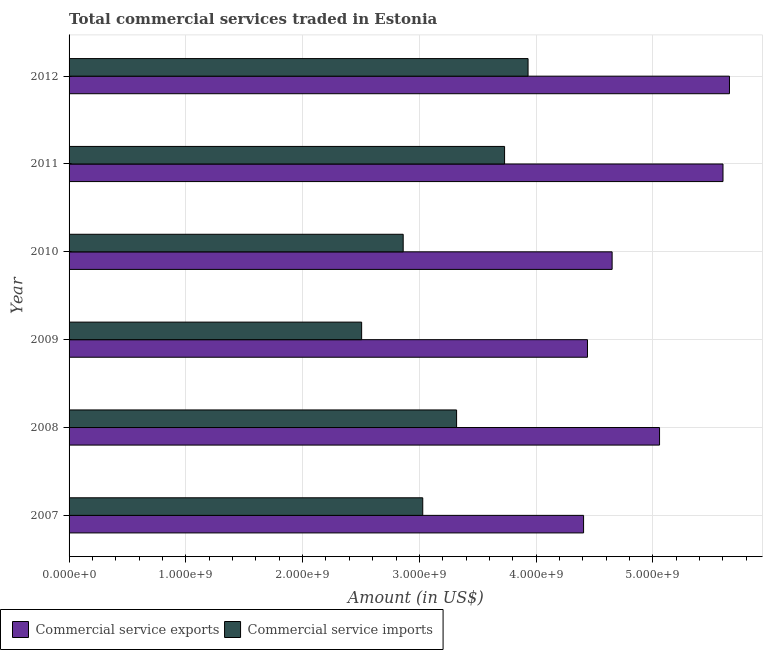How many different coloured bars are there?
Your response must be concise. 2. Are the number of bars per tick equal to the number of legend labels?
Keep it short and to the point. Yes. Are the number of bars on each tick of the Y-axis equal?
Give a very brief answer. Yes. What is the label of the 5th group of bars from the top?
Give a very brief answer. 2008. What is the amount of commercial service exports in 2009?
Your answer should be very brief. 4.44e+09. Across all years, what is the maximum amount of commercial service imports?
Your answer should be compact. 3.93e+09. Across all years, what is the minimum amount of commercial service exports?
Your answer should be very brief. 4.41e+09. In which year was the amount of commercial service exports maximum?
Ensure brevity in your answer.  2012. What is the total amount of commercial service exports in the graph?
Your answer should be compact. 2.98e+1. What is the difference between the amount of commercial service exports in 2007 and that in 2010?
Your answer should be very brief. -2.45e+08. What is the difference between the amount of commercial service exports in 2008 and the amount of commercial service imports in 2011?
Ensure brevity in your answer.  1.33e+09. What is the average amount of commercial service exports per year?
Give a very brief answer. 4.97e+09. In the year 2007, what is the difference between the amount of commercial service exports and amount of commercial service imports?
Your response must be concise. 1.38e+09. Is the difference between the amount of commercial service exports in 2007 and 2010 greater than the difference between the amount of commercial service imports in 2007 and 2010?
Ensure brevity in your answer.  No. What is the difference between the highest and the second highest amount of commercial service exports?
Your answer should be compact. 5.55e+07. What is the difference between the highest and the lowest amount of commercial service imports?
Ensure brevity in your answer.  1.43e+09. What does the 1st bar from the top in 2010 represents?
Give a very brief answer. Commercial service imports. What does the 2nd bar from the bottom in 2011 represents?
Provide a succinct answer. Commercial service imports. How many bars are there?
Your answer should be compact. 12. How many years are there in the graph?
Keep it short and to the point. 6. Does the graph contain any zero values?
Provide a succinct answer. No. What is the title of the graph?
Offer a very short reply. Total commercial services traded in Estonia. What is the label or title of the X-axis?
Your answer should be compact. Amount (in US$). What is the label or title of the Y-axis?
Your response must be concise. Year. What is the Amount (in US$) of Commercial service exports in 2007?
Ensure brevity in your answer.  4.41e+09. What is the Amount (in US$) of Commercial service imports in 2007?
Make the answer very short. 3.03e+09. What is the Amount (in US$) of Commercial service exports in 2008?
Make the answer very short. 5.06e+09. What is the Amount (in US$) of Commercial service imports in 2008?
Offer a terse response. 3.32e+09. What is the Amount (in US$) in Commercial service exports in 2009?
Keep it short and to the point. 4.44e+09. What is the Amount (in US$) of Commercial service imports in 2009?
Ensure brevity in your answer.  2.51e+09. What is the Amount (in US$) of Commercial service exports in 2010?
Offer a very short reply. 4.65e+09. What is the Amount (in US$) of Commercial service imports in 2010?
Keep it short and to the point. 2.86e+09. What is the Amount (in US$) of Commercial service exports in 2011?
Provide a short and direct response. 5.60e+09. What is the Amount (in US$) of Commercial service imports in 2011?
Your answer should be compact. 3.73e+09. What is the Amount (in US$) in Commercial service exports in 2012?
Offer a very short reply. 5.66e+09. What is the Amount (in US$) in Commercial service imports in 2012?
Ensure brevity in your answer.  3.93e+09. Across all years, what is the maximum Amount (in US$) in Commercial service exports?
Your answer should be compact. 5.66e+09. Across all years, what is the maximum Amount (in US$) in Commercial service imports?
Make the answer very short. 3.93e+09. Across all years, what is the minimum Amount (in US$) in Commercial service exports?
Give a very brief answer. 4.41e+09. Across all years, what is the minimum Amount (in US$) of Commercial service imports?
Make the answer very short. 2.51e+09. What is the total Amount (in US$) of Commercial service exports in the graph?
Make the answer very short. 2.98e+1. What is the total Amount (in US$) of Commercial service imports in the graph?
Give a very brief answer. 1.94e+1. What is the difference between the Amount (in US$) of Commercial service exports in 2007 and that in 2008?
Make the answer very short. -6.51e+08. What is the difference between the Amount (in US$) of Commercial service imports in 2007 and that in 2008?
Give a very brief answer. -2.90e+08. What is the difference between the Amount (in US$) of Commercial service exports in 2007 and that in 2009?
Your answer should be compact. -3.35e+07. What is the difference between the Amount (in US$) of Commercial service imports in 2007 and that in 2009?
Your answer should be very brief. 5.23e+08. What is the difference between the Amount (in US$) in Commercial service exports in 2007 and that in 2010?
Keep it short and to the point. -2.45e+08. What is the difference between the Amount (in US$) of Commercial service imports in 2007 and that in 2010?
Offer a very short reply. 1.67e+08. What is the difference between the Amount (in US$) in Commercial service exports in 2007 and that in 2011?
Provide a succinct answer. -1.19e+09. What is the difference between the Amount (in US$) in Commercial service imports in 2007 and that in 2011?
Provide a succinct answer. -7.01e+08. What is the difference between the Amount (in US$) in Commercial service exports in 2007 and that in 2012?
Your answer should be very brief. -1.25e+09. What is the difference between the Amount (in US$) in Commercial service imports in 2007 and that in 2012?
Provide a short and direct response. -9.02e+08. What is the difference between the Amount (in US$) of Commercial service exports in 2008 and that in 2009?
Give a very brief answer. 6.17e+08. What is the difference between the Amount (in US$) of Commercial service imports in 2008 and that in 2009?
Offer a very short reply. 8.13e+08. What is the difference between the Amount (in US$) of Commercial service exports in 2008 and that in 2010?
Keep it short and to the point. 4.06e+08. What is the difference between the Amount (in US$) of Commercial service imports in 2008 and that in 2010?
Your answer should be compact. 4.57e+08. What is the difference between the Amount (in US$) in Commercial service exports in 2008 and that in 2011?
Offer a very short reply. -5.43e+08. What is the difference between the Amount (in US$) of Commercial service imports in 2008 and that in 2011?
Provide a succinct answer. -4.11e+08. What is the difference between the Amount (in US$) of Commercial service exports in 2008 and that in 2012?
Your response must be concise. -5.99e+08. What is the difference between the Amount (in US$) of Commercial service imports in 2008 and that in 2012?
Your response must be concise. -6.12e+08. What is the difference between the Amount (in US$) of Commercial service exports in 2009 and that in 2010?
Offer a terse response. -2.11e+08. What is the difference between the Amount (in US$) of Commercial service imports in 2009 and that in 2010?
Keep it short and to the point. -3.56e+08. What is the difference between the Amount (in US$) of Commercial service exports in 2009 and that in 2011?
Keep it short and to the point. -1.16e+09. What is the difference between the Amount (in US$) of Commercial service imports in 2009 and that in 2011?
Give a very brief answer. -1.22e+09. What is the difference between the Amount (in US$) of Commercial service exports in 2009 and that in 2012?
Your response must be concise. -1.22e+09. What is the difference between the Amount (in US$) in Commercial service imports in 2009 and that in 2012?
Give a very brief answer. -1.43e+09. What is the difference between the Amount (in US$) of Commercial service exports in 2010 and that in 2011?
Offer a very short reply. -9.50e+08. What is the difference between the Amount (in US$) of Commercial service imports in 2010 and that in 2011?
Keep it short and to the point. -8.68e+08. What is the difference between the Amount (in US$) in Commercial service exports in 2010 and that in 2012?
Your response must be concise. -1.01e+09. What is the difference between the Amount (in US$) in Commercial service imports in 2010 and that in 2012?
Keep it short and to the point. -1.07e+09. What is the difference between the Amount (in US$) of Commercial service exports in 2011 and that in 2012?
Your response must be concise. -5.55e+07. What is the difference between the Amount (in US$) of Commercial service imports in 2011 and that in 2012?
Provide a short and direct response. -2.01e+08. What is the difference between the Amount (in US$) in Commercial service exports in 2007 and the Amount (in US$) in Commercial service imports in 2008?
Keep it short and to the point. 1.09e+09. What is the difference between the Amount (in US$) of Commercial service exports in 2007 and the Amount (in US$) of Commercial service imports in 2009?
Keep it short and to the point. 1.90e+09. What is the difference between the Amount (in US$) in Commercial service exports in 2007 and the Amount (in US$) in Commercial service imports in 2010?
Your response must be concise. 1.54e+09. What is the difference between the Amount (in US$) in Commercial service exports in 2007 and the Amount (in US$) in Commercial service imports in 2011?
Offer a very short reply. 6.77e+08. What is the difference between the Amount (in US$) of Commercial service exports in 2007 and the Amount (in US$) of Commercial service imports in 2012?
Make the answer very short. 4.75e+08. What is the difference between the Amount (in US$) of Commercial service exports in 2008 and the Amount (in US$) of Commercial service imports in 2009?
Offer a terse response. 2.55e+09. What is the difference between the Amount (in US$) of Commercial service exports in 2008 and the Amount (in US$) of Commercial service imports in 2010?
Provide a succinct answer. 2.20e+09. What is the difference between the Amount (in US$) in Commercial service exports in 2008 and the Amount (in US$) in Commercial service imports in 2011?
Give a very brief answer. 1.33e+09. What is the difference between the Amount (in US$) in Commercial service exports in 2008 and the Amount (in US$) in Commercial service imports in 2012?
Provide a short and direct response. 1.13e+09. What is the difference between the Amount (in US$) of Commercial service exports in 2009 and the Amount (in US$) of Commercial service imports in 2010?
Give a very brief answer. 1.58e+09. What is the difference between the Amount (in US$) in Commercial service exports in 2009 and the Amount (in US$) in Commercial service imports in 2011?
Your answer should be very brief. 7.10e+08. What is the difference between the Amount (in US$) of Commercial service exports in 2009 and the Amount (in US$) of Commercial service imports in 2012?
Keep it short and to the point. 5.09e+08. What is the difference between the Amount (in US$) in Commercial service exports in 2010 and the Amount (in US$) in Commercial service imports in 2011?
Offer a very short reply. 9.21e+08. What is the difference between the Amount (in US$) of Commercial service exports in 2010 and the Amount (in US$) of Commercial service imports in 2012?
Offer a terse response. 7.20e+08. What is the difference between the Amount (in US$) in Commercial service exports in 2011 and the Amount (in US$) in Commercial service imports in 2012?
Provide a succinct answer. 1.67e+09. What is the average Amount (in US$) of Commercial service exports per year?
Your response must be concise. 4.97e+09. What is the average Amount (in US$) of Commercial service imports per year?
Provide a succinct answer. 3.23e+09. In the year 2007, what is the difference between the Amount (in US$) in Commercial service exports and Amount (in US$) in Commercial service imports?
Make the answer very short. 1.38e+09. In the year 2008, what is the difference between the Amount (in US$) in Commercial service exports and Amount (in US$) in Commercial service imports?
Provide a short and direct response. 1.74e+09. In the year 2009, what is the difference between the Amount (in US$) of Commercial service exports and Amount (in US$) of Commercial service imports?
Provide a short and direct response. 1.93e+09. In the year 2010, what is the difference between the Amount (in US$) in Commercial service exports and Amount (in US$) in Commercial service imports?
Your answer should be compact. 1.79e+09. In the year 2011, what is the difference between the Amount (in US$) in Commercial service exports and Amount (in US$) in Commercial service imports?
Your response must be concise. 1.87e+09. In the year 2012, what is the difference between the Amount (in US$) in Commercial service exports and Amount (in US$) in Commercial service imports?
Your response must be concise. 1.73e+09. What is the ratio of the Amount (in US$) in Commercial service exports in 2007 to that in 2008?
Provide a succinct answer. 0.87. What is the ratio of the Amount (in US$) of Commercial service imports in 2007 to that in 2008?
Your answer should be compact. 0.91. What is the ratio of the Amount (in US$) of Commercial service exports in 2007 to that in 2009?
Your response must be concise. 0.99. What is the ratio of the Amount (in US$) of Commercial service imports in 2007 to that in 2009?
Provide a short and direct response. 1.21. What is the ratio of the Amount (in US$) in Commercial service imports in 2007 to that in 2010?
Offer a very short reply. 1.06. What is the ratio of the Amount (in US$) in Commercial service exports in 2007 to that in 2011?
Provide a short and direct response. 0.79. What is the ratio of the Amount (in US$) of Commercial service imports in 2007 to that in 2011?
Your answer should be compact. 0.81. What is the ratio of the Amount (in US$) in Commercial service exports in 2007 to that in 2012?
Your answer should be very brief. 0.78. What is the ratio of the Amount (in US$) in Commercial service imports in 2007 to that in 2012?
Ensure brevity in your answer.  0.77. What is the ratio of the Amount (in US$) in Commercial service exports in 2008 to that in 2009?
Make the answer very short. 1.14. What is the ratio of the Amount (in US$) of Commercial service imports in 2008 to that in 2009?
Ensure brevity in your answer.  1.32. What is the ratio of the Amount (in US$) in Commercial service exports in 2008 to that in 2010?
Offer a terse response. 1.09. What is the ratio of the Amount (in US$) of Commercial service imports in 2008 to that in 2010?
Provide a short and direct response. 1.16. What is the ratio of the Amount (in US$) in Commercial service exports in 2008 to that in 2011?
Provide a succinct answer. 0.9. What is the ratio of the Amount (in US$) of Commercial service imports in 2008 to that in 2011?
Keep it short and to the point. 0.89. What is the ratio of the Amount (in US$) in Commercial service exports in 2008 to that in 2012?
Give a very brief answer. 0.89. What is the ratio of the Amount (in US$) in Commercial service imports in 2008 to that in 2012?
Provide a short and direct response. 0.84. What is the ratio of the Amount (in US$) of Commercial service exports in 2009 to that in 2010?
Your response must be concise. 0.95. What is the ratio of the Amount (in US$) in Commercial service imports in 2009 to that in 2010?
Keep it short and to the point. 0.88. What is the ratio of the Amount (in US$) in Commercial service exports in 2009 to that in 2011?
Keep it short and to the point. 0.79. What is the ratio of the Amount (in US$) in Commercial service imports in 2009 to that in 2011?
Keep it short and to the point. 0.67. What is the ratio of the Amount (in US$) of Commercial service exports in 2009 to that in 2012?
Give a very brief answer. 0.79. What is the ratio of the Amount (in US$) in Commercial service imports in 2009 to that in 2012?
Provide a succinct answer. 0.64. What is the ratio of the Amount (in US$) of Commercial service exports in 2010 to that in 2011?
Your response must be concise. 0.83. What is the ratio of the Amount (in US$) of Commercial service imports in 2010 to that in 2011?
Make the answer very short. 0.77. What is the ratio of the Amount (in US$) of Commercial service exports in 2010 to that in 2012?
Keep it short and to the point. 0.82. What is the ratio of the Amount (in US$) of Commercial service imports in 2010 to that in 2012?
Your answer should be compact. 0.73. What is the ratio of the Amount (in US$) of Commercial service exports in 2011 to that in 2012?
Your answer should be compact. 0.99. What is the ratio of the Amount (in US$) in Commercial service imports in 2011 to that in 2012?
Provide a succinct answer. 0.95. What is the difference between the highest and the second highest Amount (in US$) in Commercial service exports?
Ensure brevity in your answer.  5.55e+07. What is the difference between the highest and the second highest Amount (in US$) in Commercial service imports?
Ensure brevity in your answer.  2.01e+08. What is the difference between the highest and the lowest Amount (in US$) in Commercial service exports?
Give a very brief answer. 1.25e+09. What is the difference between the highest and the lowest Amount (in US$) in Commercial service imports?
Offer a very short reply. 1.43e+09. 